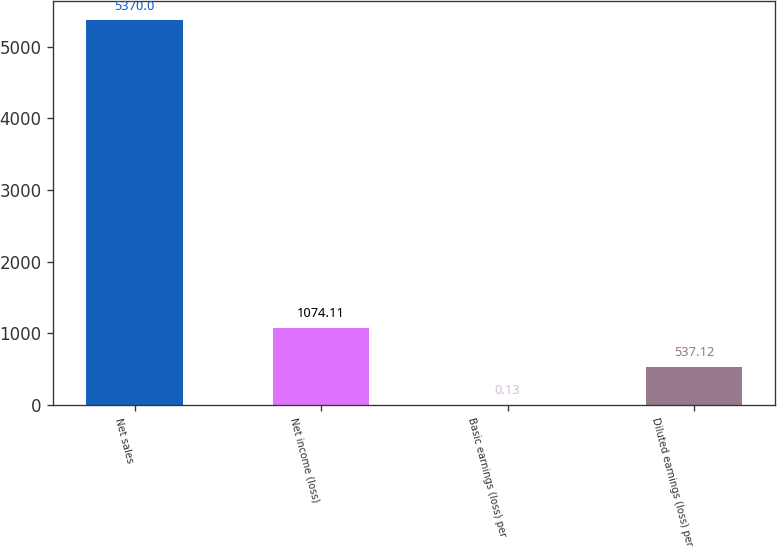Convert chart. <chart><loc_0><loc_0><loc_500><loc_500><bar_chart><fcel>Net sales<fcel>Net income (loss)<fcel>Basic earnings (loss) per<fcel>Diluted earnings (loss) per<nl><fcel>5370<fcel>1074.11<fcel>0.13<fcel>537.12<nl></chart> 